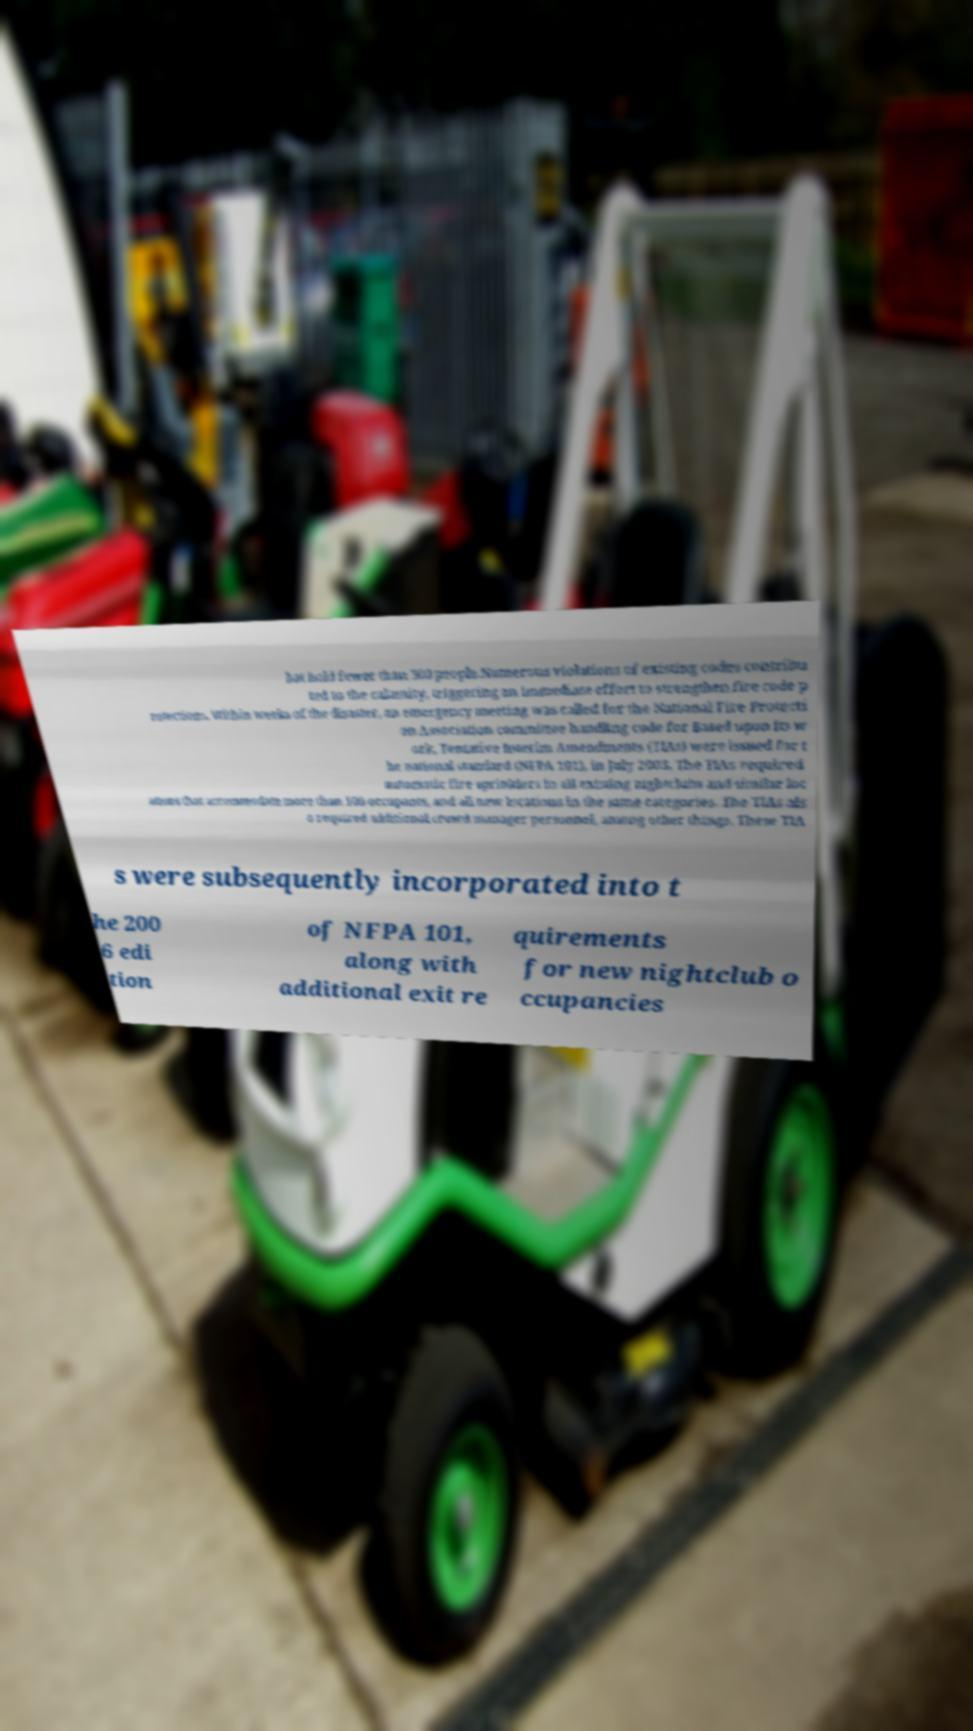Can you read and provide the text displayed in the image?This photo seems to have some interesting text. Can you extract and type it out for me? hat hold fewer than 300 people.Numerous violations of existing codes contribu ted to the calamity, triggering an immediate effort to strengthen fire code p rotections. Within weeks of the disaster, an emergency meeting was called for the National Fire Protecti on Association committee handling code for Based upon its w ork, Tentative Interim Amendments (TIAs) were issued for t he national standard (NFPA 101), in July 2003. The TIAs required automatic fire sprinklers in all existing nightclubs and similar loc ations that accommodate more than 100 occupants, and all new locations in the same categories. The TIAs als o required additional crowd manager personnel, among other things. These TIA s were subsequently incorporated into t he 200 6 edi tion of NFPA 101, along with additional exit re quirements for new nightclub o ccupancies 